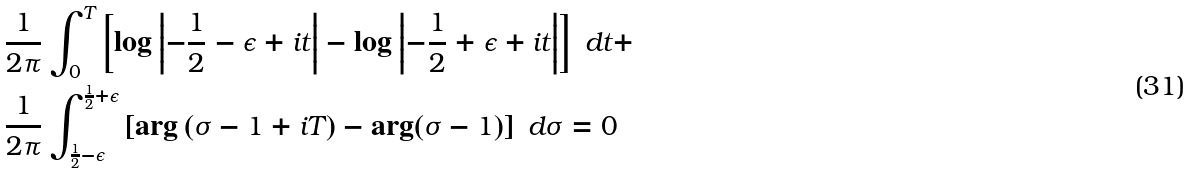<formula> <loc_0><loc_0><loc_500><loc_500>& \frac { 1 } { 2 \pi } \int _ { 0 } ^ { T } \left [ \log \left | - \frac { 1 } { 2 } - \epsilon + i t \right | - \log \left | - \frac { 1 } { 2 } + \epsilon + i t \right | \right ] \ d t + \\ & \frac { 1 } { 2 \pi } \int _ { \frac { 1 } { 2 } - \epsilon } ^ { \frac { 1 } { 2 } + \epsilon } \left [ \arg \left ( \sigma - 1 + i T \right ) - \arg ( \sigma - 1 ) \right ] \ d \sigma = 0</formula> 